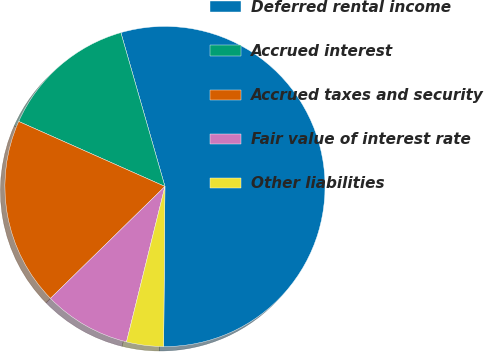<chart> <loc_0><loc_0><loc_500><loc_500><pie_chart><fcel>Deferred rental income<fcel>Accrued interest<fcel>Accrued taxes and security<fcel>Fair value of interest rate<fcel>Other liabilities<nl><fcel>54.57%<fcel>13.9%<fcel>18.98%<fcel>8.82%<fcel>3.73%<nl></chart> 